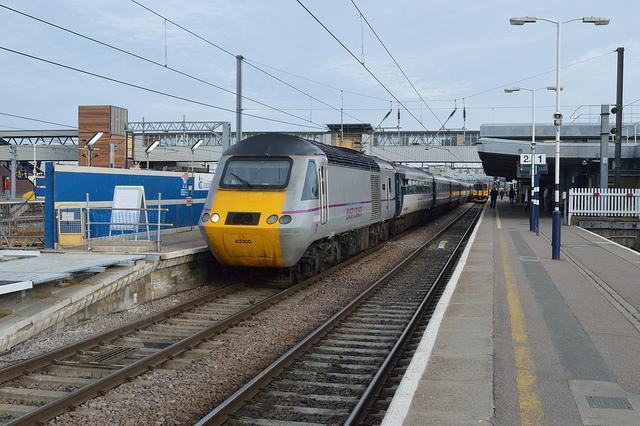Which train is safest to board for those on our right?
Answer the question by selecting the correct answer among the 4 following choices.
Options: Near arriving, gray furthest, none, any. Near arriving. 